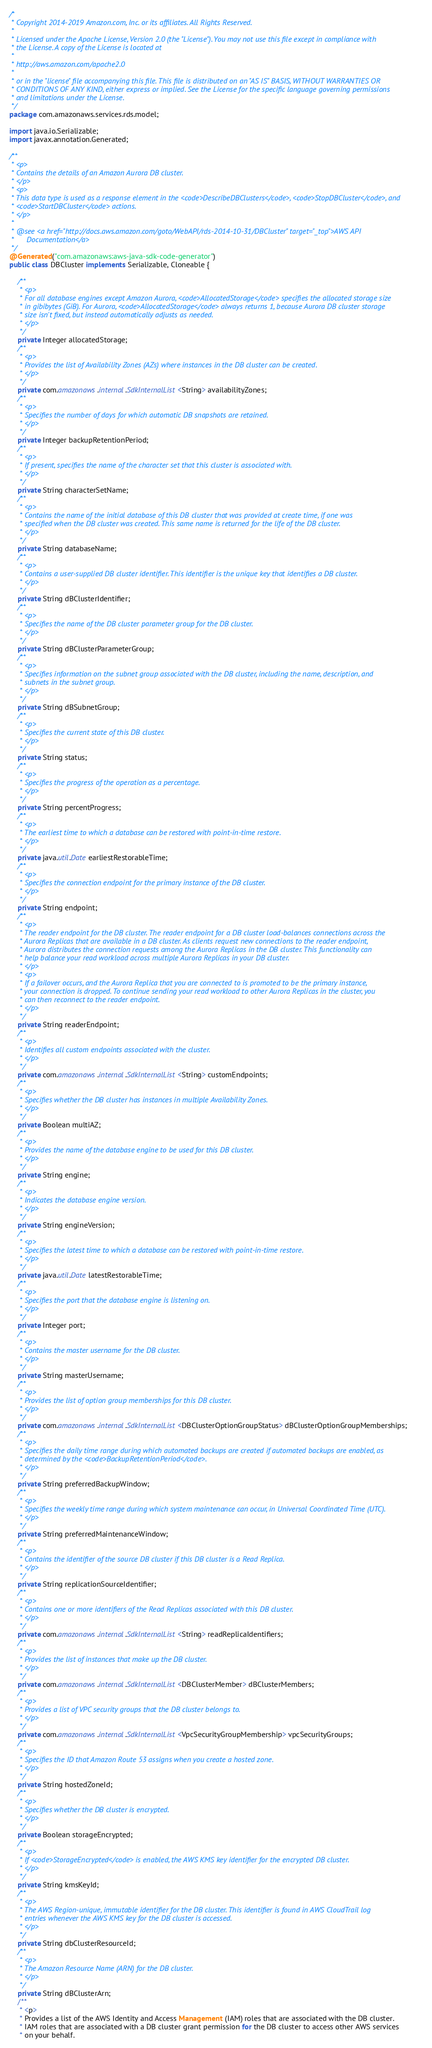Convert code to text. <code><loc_0><loc_0><loc_500><loc_500><_Java_>/*
 * Copyright 2014-2019 Amazon.com, Inc. or its affiliates. All Rights Reserved.
 * 
 * Licensed under the Apache License, Version 2.0 (the "License"). You may not use this file except in compliance with
 * the License. A copy of the License is located at
 * 
 * http://aws.amazon.com/apache2.0
 * 
 * or in the "license" file accompanying this file. This file is distributed on an "AS IS" BASIS, WITHOUT WARRANTIES OR
 * CONDITIONS OF ANY KIND, either express or implied. See the License for the specific language governing permissions
 * and limitations under the License.
 */
package com.amazonaws.services.rds.model;

import java.io.Serializable;
import javax.annotation.Generated;

/**
 * <p>
 * Contains the details of an Amazon Aurora DB cluster.
 * </p>
 * <p>
 * This data type is used as a response element in the <code>DescribeDBClusters</code>, <code>StopDBCluster</code>, and
 * <code>StartDBCluster</code> actions.
 * </p>
 * 
 * @see <a href="http://docs.aws.amazon.com/goto/WebAPI/rds-2014-10-31/DBCluster" target="_top">AWS API
 *      Documentation</a>
 */
@Generated("com.amazonaws:aws-java-sdk-code-generator")
public class DBCluster implements Serializable, Cloneable {

    /**
     * <p>
     * For all database engines except Amazon Aurora, <code>AllocatedStorage</code> specifies the allocated storage size
     * in gibibytes (GiB). For Aurora, <code>AllocatedStorage</code> always returns 1, because Aurora DB cluster storage
     * size isn't fixed, but instead automatically adjusts as needed.
     * </p>
     */
    private Integer allocatedStorage;
    /**
     * <p>
     * Provides the list of Availability Zones (AZs) where instances in the DB cluster can be created.
     * </p>
     */
    private com.amazonaws.internal.SdkInternalList<String> availabilityZones;
    /**
     * <p>
     * Specifies the number of days for which automatic DB snapshots are retained.
     * </p>
     */
    private Integer backupRetentionPeriod;
    /**
     * <p>
     * If present, specifies the name of the character set that this cluster is associated with.
     * </p>
     */
    private String characterSetName;
    /**
     * <p>
     * Contains the name of the initial database of this DB cluster that was provided at create time, if one was
     * specified when the DB cluster was created. This same name is returned for the life of the DB cluster.
     * </p>
     */
    private String databaseName;
    /**
     * <p>
     * Contains a user-supplied DB cluster identifier. This identifier is the unique key that identifies a DB cluster.
     * </p>
     */
    private String dBClusterIdentifier;
    /**
     * <p>
     * Specifies the name of the DB cluster parameter group for the DB cluster.
     * </p>
     */
    private String dBClusterParameterGroup;
    /**
     * <p>
     * Specifies information on the subnet group associated with the DB cluster, including the name, description, and
     * subnets in the subnet group.
     * </p>
     */
    private String dBSubnetGroup;
    /**
     * <p>
     * Specifies the current state of this DB cluster.
     * </p>
     */
    private String status;
    /**
     * <p>
     * Specifies the progress of the operation as a percentage.
     * </p>
     */
    private String percentProgress;
    /**
     * <p>
     * The earliest time to which a database can be restored with point-in-time restore.
     * </p>
     */
    private java.util.Date earliestRestorableTime;
    /**
     * <p>
     * Specifies the connection endpoint for the primary instance of the DB cluster.
     * </p>
     */
    private String endpoint;
    /**
     * <p>
     * The reader endpoint for the DB cluster. The reader endpoint for a DB cluster load-balances connections across the
     * Aurora Replicas that are available in a DB cluster. As clients request new connections to the reader endpoint,
     * Aurora distributes the connection requests among the Aurora Replicas in the DB cluster. This functionality can
     * help balance your read workload across multiple Aurora Replicas in your DB cluster.
     * </p>
     * <p>
     * If a failover occurs, and the Aurora Replica that you are connected to is promoted to be the primary instance,
     * your connection is dropped. To continue sending your read workload to other Aurora Replicas in the cluster, you
     * can then reconnect to the reader endpoint.
     * </p>
     */
    private String readerEndpoint;
    /**
     * <p>
     * Identifies all custom endpoints associated with the cluster.
     * </p>
     */
    private com.amazonaws.internal.SdkInternalList<String> customEndpoints;
    /**
     * <p>
     * Specifies whether the DB cluster has instances in multiple Availability Zones.
     * </p>
     */
    private Boolean multiAZ;
    /**
     * <p>
     * Provides the name of the database engine to be used for this DB cluster.
     * </p>
     */
    private String engine;
    /**
     * <p>
     * Indicates the database engine version.
     * </p>
     */
    private String engineVersion;
    /**
     * <p>
     * Specifies the latest time to which a database can be restored with point-in-time restore.
     * </p>
     */
    private java.util.Date latestRestorableTime;
    /**
     * <p>
     * Specifies the port that the database engine is listening on.
     * </p>
     */
    private Integer port;
    /**
     * <p>
     * Contains the master username for the DB cluster.
     * </p>
     */
    private String masterUsername;
    /**
     * <p>
     * Provides the list of option group memberships for this DB cluster.
     * </p>
     */
    private com.amazonaws.internal.SdkInternalList<DBClusterOptionGroupStatus> dBClusterOptionGroupMemberships;
    /**
     * <p>
     * Specifies the daily time range during which automated backups are created if automated backups are enabled, as
     * determined by the <code>BackupRetentionPeriod</code>.
     * </p>
     */
    private String preferredBackupWindow;
    /**
     * <p>
     * Specifies the weekly time range during which system maintenance can occur, in Universal Coordinated Time (UTC).
     * </p>
     */
    private String preferredMaintenanceWindow;
    /**
     * <p>
     * Contains the identifier of the source DB cluster if this DB cluster is a Read Replica.
     * </p>
     */
    private String replicationSourceIdentifier;
    /**
     * <p>
     * Contains one or more identifiers of the Read Replicas associated with this DB cluster.
     * </p>
     */
    private com.amazonaws.internal.SdkInternalList<String> readReplicaIdentifiers;
    /**
     * <p>
     * Provides the list of instances that make up the DB cluster.
     * </p>
     */
    private com.amazonaws.internal.SdkInternalList<DBClusterMember> dBClusterMembers;
    /**
     * <p>
     * Provides a list of VPC security groups that the DB cluster belongs to.
     * </p>
     */
    private com.amazonaws.internal.SdkInternalList<VpcSecurityGroupMembership> vpcSecurityGroups;
    /**
     * <p>
     * Specifies the ID that Amazon Route 53 assigns when you create a hosted zone.
     * </p>
     */
    private String hostedZoneId;
    /**
     * <p>
     * Specifies whether the DB cluster is encrypted.
     * </p>
     */
    private Boolean storageEncrypted;
    /**
     * <p>
     * If <code>StorageEncrypted</code> is enabled, the AWS KMS key identifier for the encrypted DB cluster.
     * </p>
     */
    private String kmsKeyId;
    /**
     * <p>
     * The AWS Region-unique, immutable identifier for the DB cluster. This identifier is found in AWS CloudTrail log
     * entries whenever the AWS KMS key for the DB cluster is accessed.
     * </p>
     */
    private String dbClusterResourceId;
    /**
     * <p>
     * The Amazon Resource Name (ARN) for the DB cluster.
     * </p>
     */
    private String dBClusterArn;
    /**
     * <p>
     * Provides a list of the AWS Identity and Access Management (IAM) roles that are associated with the DB cluster.
     * IAM roles that are associated with a DB cluster grant permission for the DB cluster to access other AWS services
     * on your behalf.</code> 